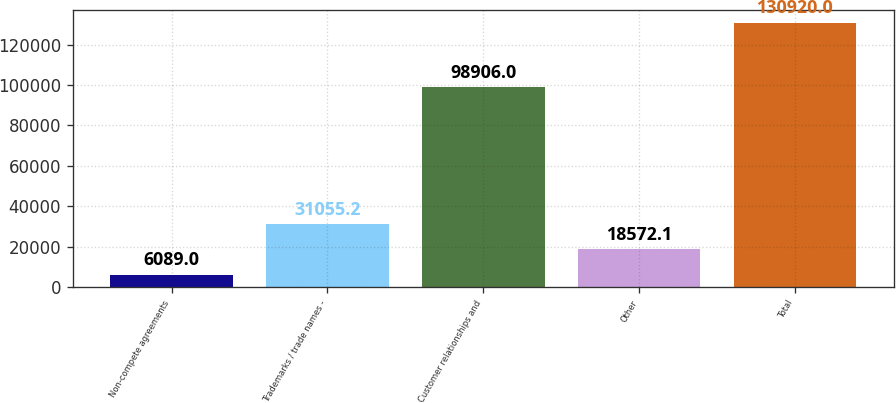Convert chart to OTSL. <chart><loc_0><loc_0><loc_500><loc_500><bar_chart><fcel>Non-compete agreements<fcel>Trademarks / trade names -<fcel>Customer relationships and<fcel>Other<fcel>Total<nl><fcel>6089<fcel>31055.2<fcel>98906<fcel>18572.1<fcel>130920<nl></chart> 